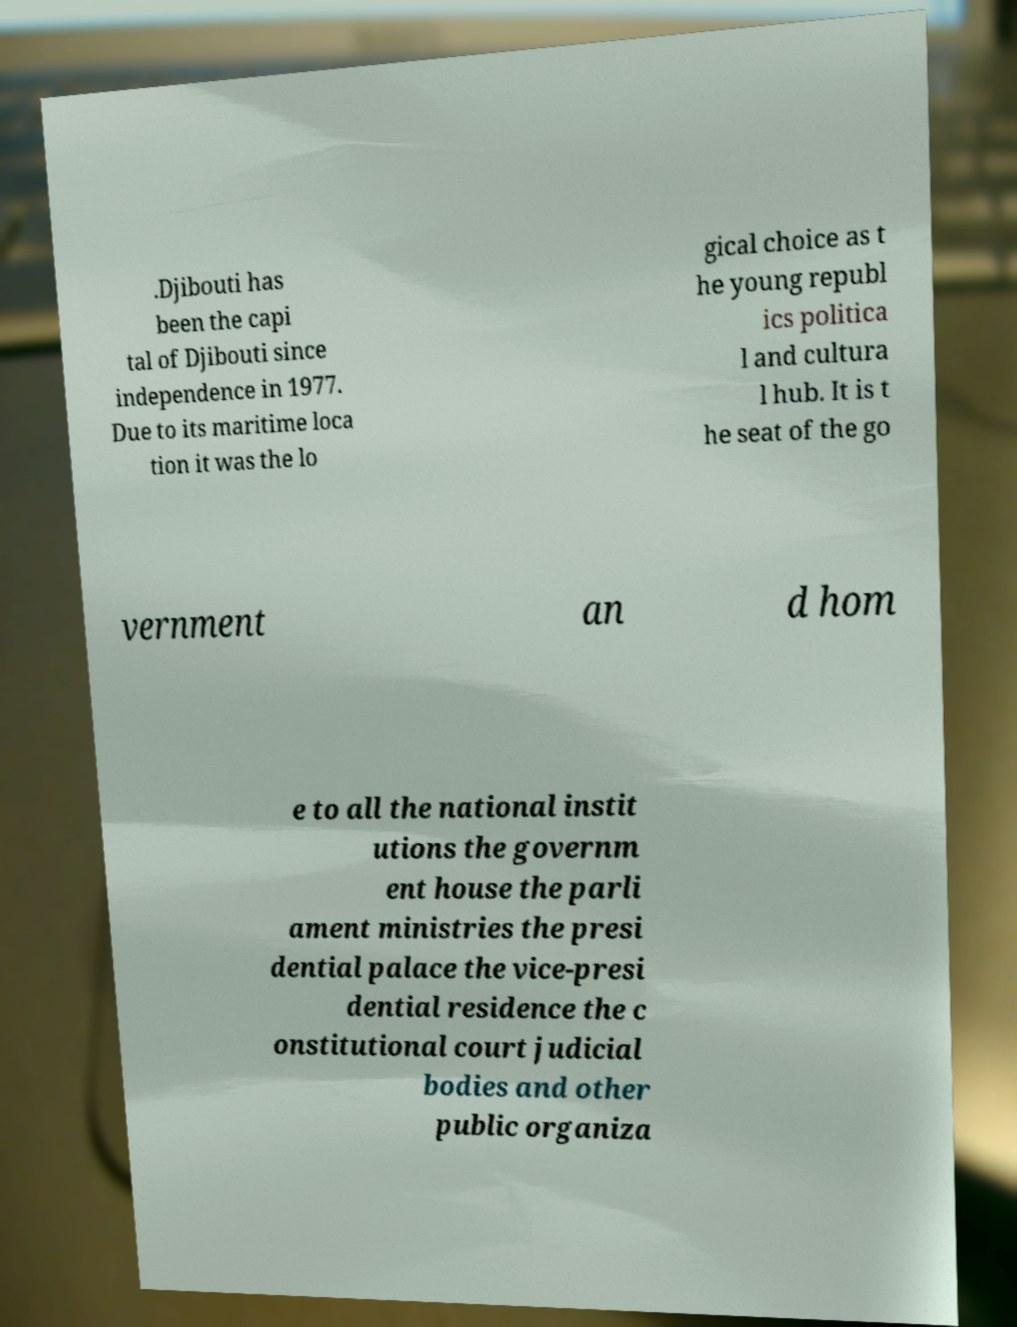For documentation purposes, I need the text within this image transcribed. Could you provide that? .Djibouti has been the capi tal of Djibouti since independence in 1977. Due to its maritime loca tion it was the lo gical choice as t he young republ ics politica l and cultura l hub. It is t he seat of the go vernment an d hom e to all the national instit utions the governm ent house the parli ament ministries the presi dential palace the vice-presi dential residence the c onstitutional court judicial bodies and other public organiza 